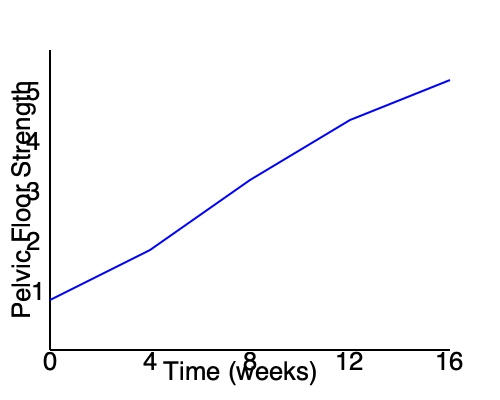Based on the line graph showing the effectiveness of pelvic floor exercises over time, what can be concluded about the rate of improvement in pelvic floor strength? To analyze the rate of improvement in pelvic floor strength, we need to examine the slope of the line at different points:

1. Start by identifying the overall trend: The line shows an upward trajectory, indicating an improvement in pelvic floor strength over time.

2. Examine the slope at different intervals:
   - From 0 to 4 weeks: The slope is steepest, indicating rapid improvement.
   - From 4 to 8 weeks: The slope is still positive but less steep than the first interval.
   - From 8 to 12 weeks: The slope continues to decrease but remains positive.
   - From 12 to 16 weeks: The slope is the least steep, showing the slowest rate of improvement.

3. Calculate the rate of change:
   Let's define the rate of change as $\frac{\Delta y}{\Delta x}$, where $y$ is pelvic floor strength and $x$ is time in weeks.
   
   - 0-4 weeks: $\frac{2-1}{4-0} = \frac{1}{4} = 0.25$ units/week
   - 4-8 weeks: $\frac{3-2}{8-4} = \frac{1}{4} = 0.25$ units/week
   - 8-12 weeks: $\frac{4-3}{12-8} = \frac{1}{4} = 0.25$ units/week
   - 12-16 weeks: $\frac{4.5-4}{16-12} = \frac{0.5}{4} = 0.125$ units/week

4. Interpret the results:
   The rate of improvement is consistent for the first 12 weeks at 0.25 units/week, then decreases to 0.125 units/week for the last 4 weeks.

Therefore, we can conclude that the rate of improvement in pelvic floor strength is initially steady and then decreases over time, with the most significant gains occurring in the earlier weeks of the exercise program.
Answer: The rate of improvement is initially steady and then decreases over time. 